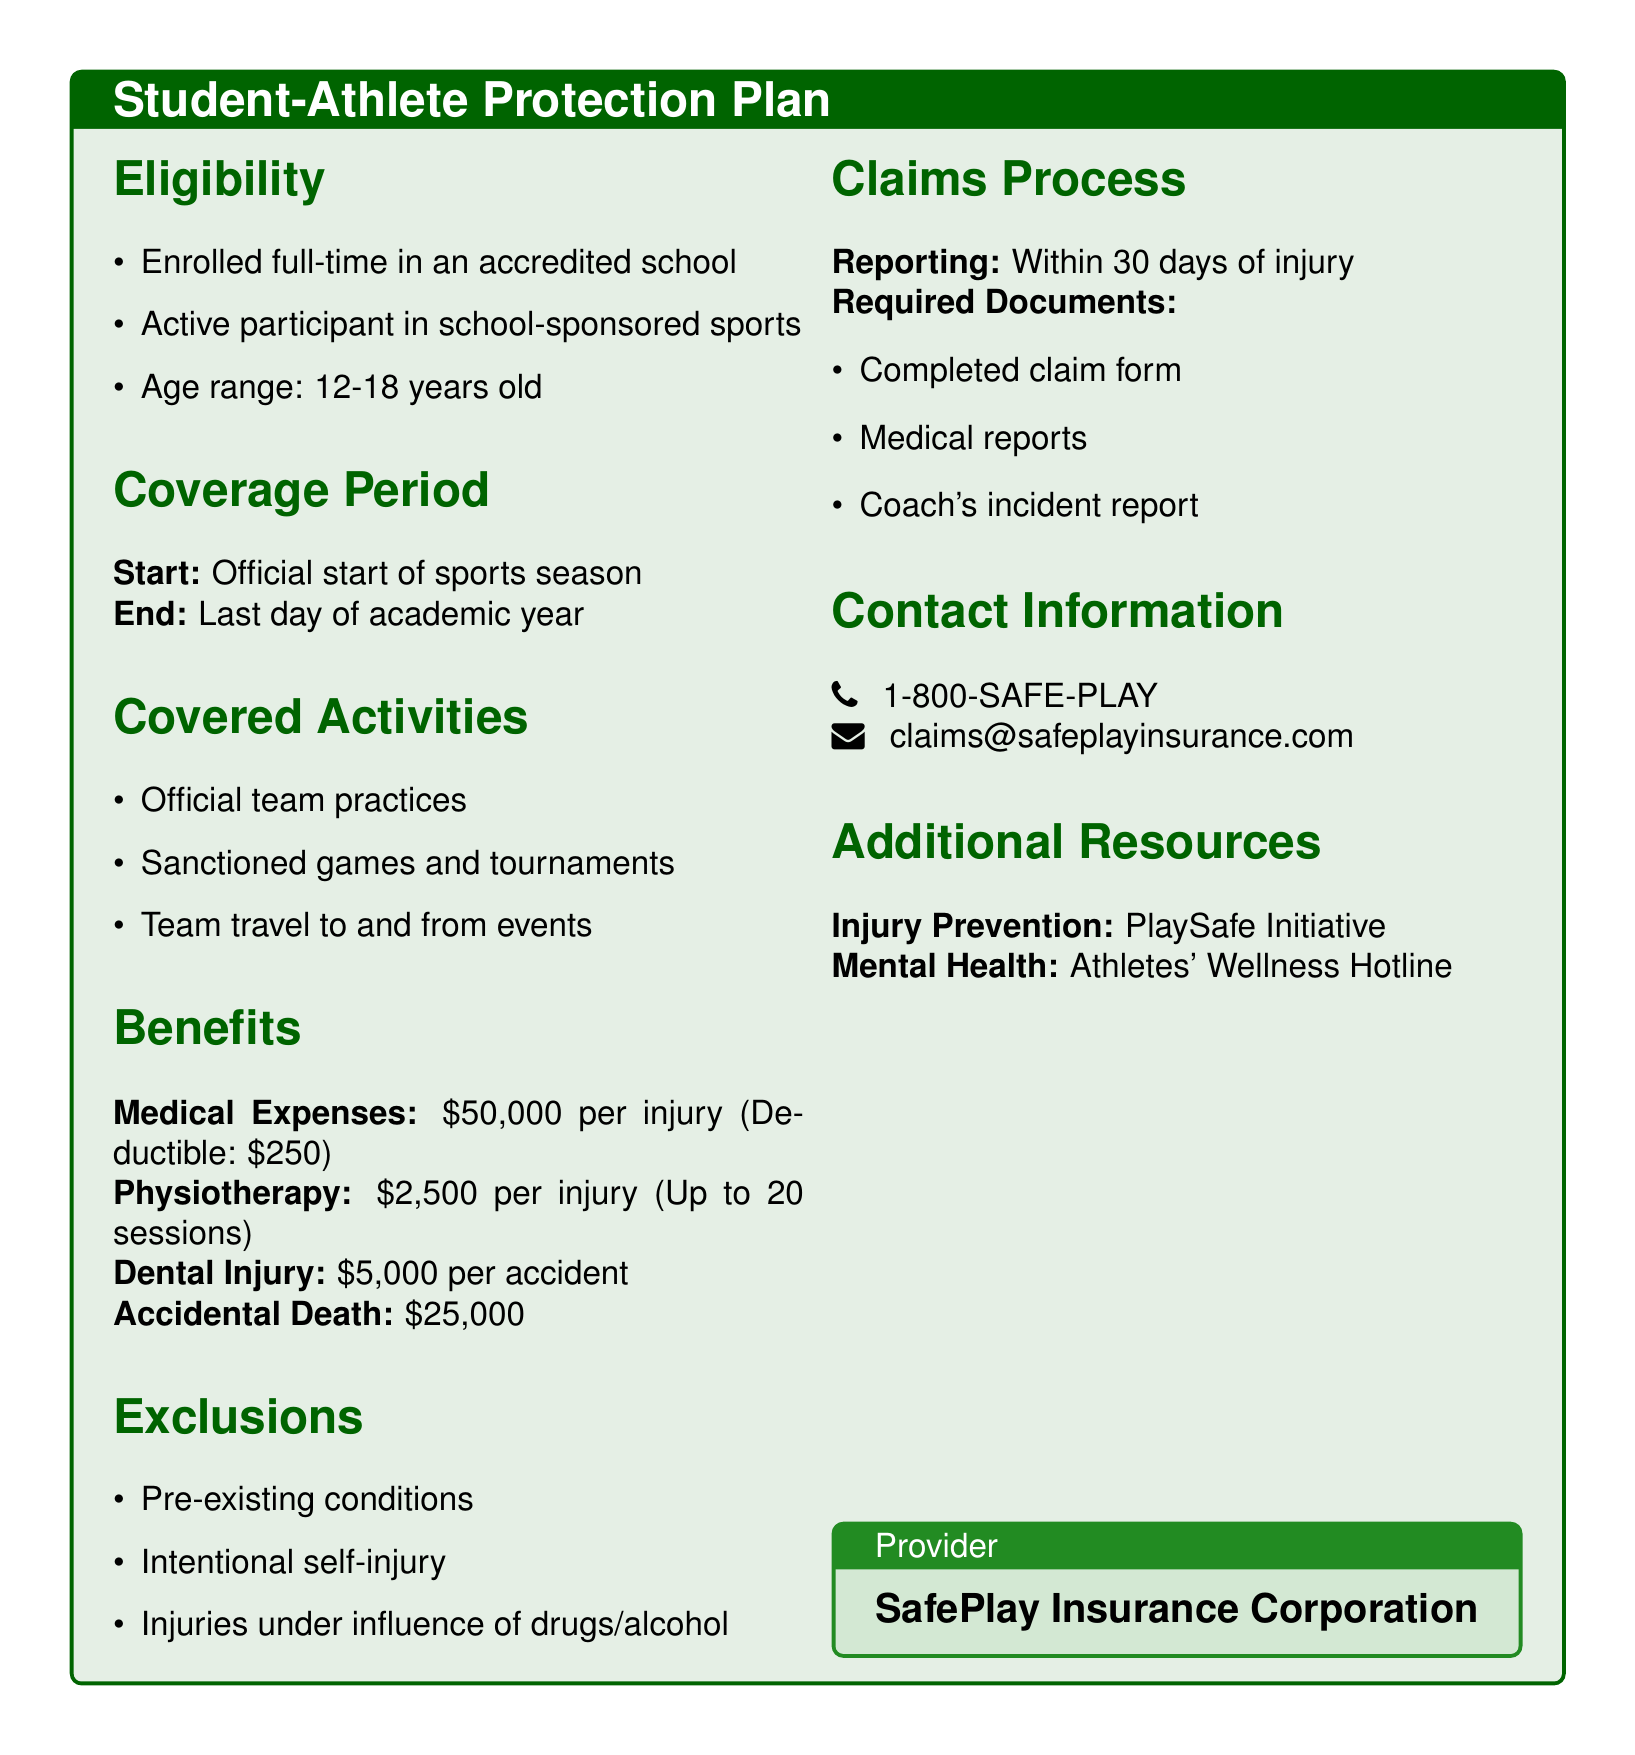What is the age range for eligibility? The document specifies the age range of eligible student-athletes, which is 12 to 18 years old.
Answer: 12-18 years old What is the deductible for medical expenses? The deductible amount that applies to the medical expenses coverage is stated in the document.
Answer: $250 Which activities are covered under this policy? The policy outlines specific activities that are covered, including official team practices, sanctioned games, and team travel.
Answer: Official team practices, Sanctioned games and tournaments, Team travel to and from events What is the benefit for accidental death? The document states the amount of coverage provided in case of accidental death, which is listed under benefits.
Answer: $25,000 What is the maximum benefit for physiotherapy? The document mentions the maximum coverage amount for physiotherapy per injury.
Answer: $2,500 What type of injuries are excluded from coverage? The document outlines specific exclusions related to the coverage, which includes pre-existing conditions and intentional self-injury.
Answer: Pre-existing conditions, Intentional self-injury, Injuries under influence of drugs/alcohol What is the claims reporting timeline? The document specifies how soon after an injury a claim must be reported.
Answer: Within 30 days of injury Who is the provider of this insurance? The document lists the name of the insurance corporation providing the student-athlete protection plan.
Answer: SafePlay Insurance Corporation How many physiotherapy sessions are covered? The document specifies the maximum number of physiotherapy sessions that can be covered per injury.
Answer: Up to 20 sessions 